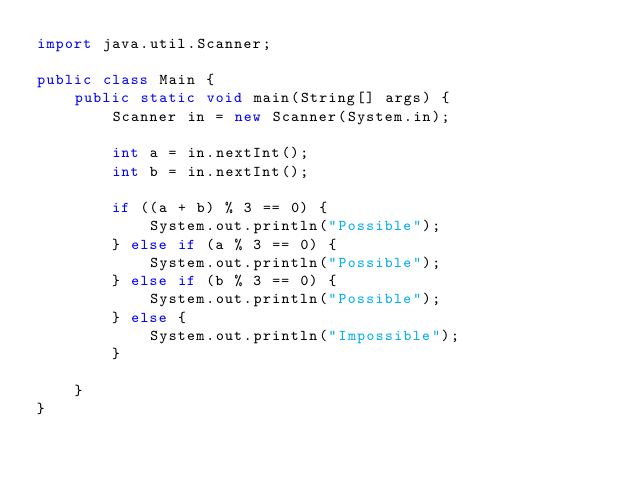Convert code to text. <code><loc_0><loc_0><loc_500><loc_500><_Java_>import java.util.Scanner;

public class Main {
	public static void main(String[] args) {
		Scanner in = new Scanner(System.in);

		int a = in.nextInt();
		int b = in.nextInt();

		if ((a + b) % 3 == 0) {
			System.out.println("Possible");
		} else if (a % 3 == 0) {
			System.out.println("Possible");
		} else if (b % 3 == 0) {
			System.out.println("Possible");
		} else {
			System.out.println("Impossible");
		}

	}
}</code> 